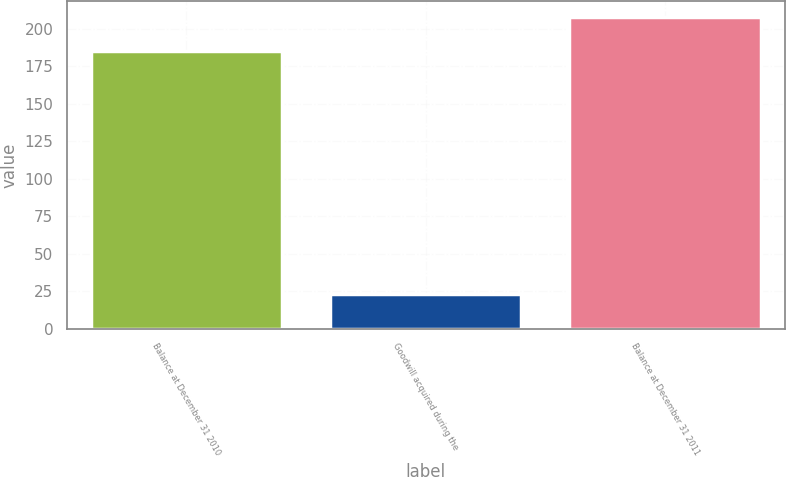Convert chart. <chart><loc_0><loc_0><loc_500><loc_500><bar_chart><fcel>Balance at December 31 2010<fcel>Goodwill acquired during the<fcel>Balance at December 31 2011<nl><fcel>185<fcel>23<fcel>208<nl></chart> 